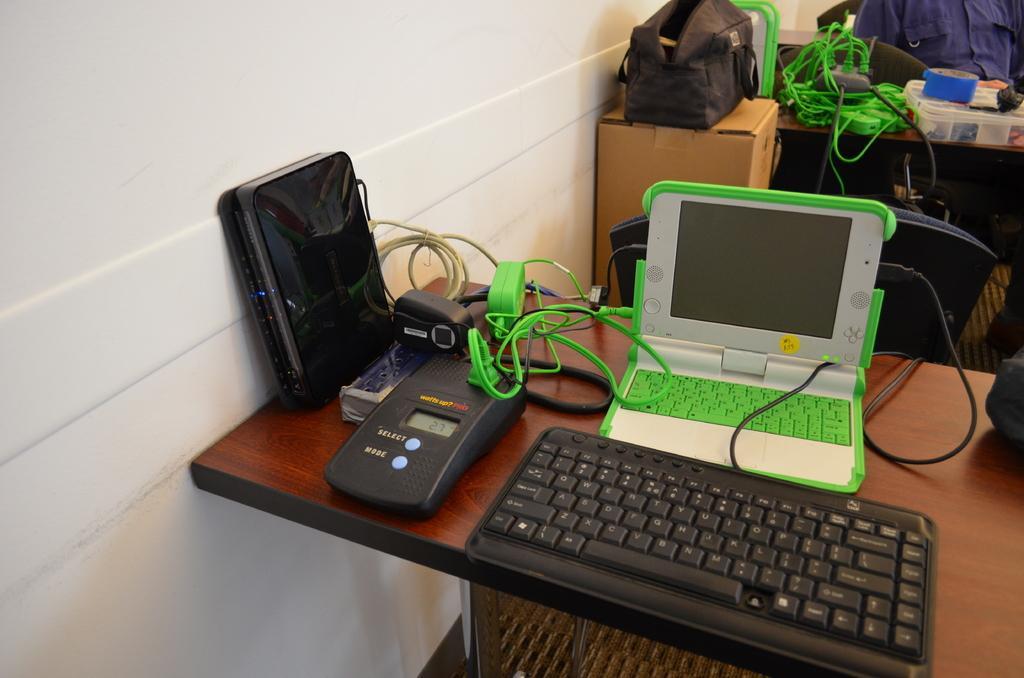Please provide a concise description of this image. On this table there is a keyboard, laptop, devices and cables. On this cardboard box there is a bag. A person is sitting on a chair. In-front of this person there is a table, on this table there is a box, cables and tape. 